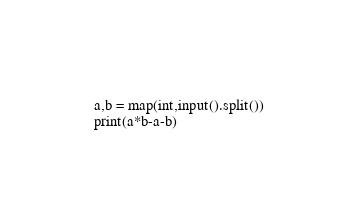Convert code to text. <code><loc_0><loc_0><loc_500><loc_500><_Python_>a,b = map(int,input().split())
print(a*b-a-b)</code> 